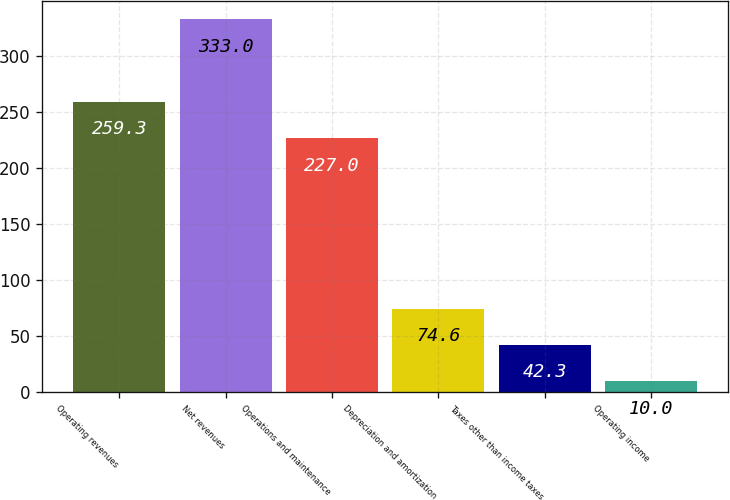Convert chart. <chart><loc_0><loc_0><loc_500><loc_500><bar_chart><fcel>Operating revenues<fcel>Net revenues<fcel>Operations and maintenance<fcel>Depreciation and amortization<fcel>Taxes other than income taxes<fcel>Operating income<nl><fcel>259.3<fcel>333<fcel>227<fcel>74.6<fcel>42.3<fcel>10<nl></chart> 